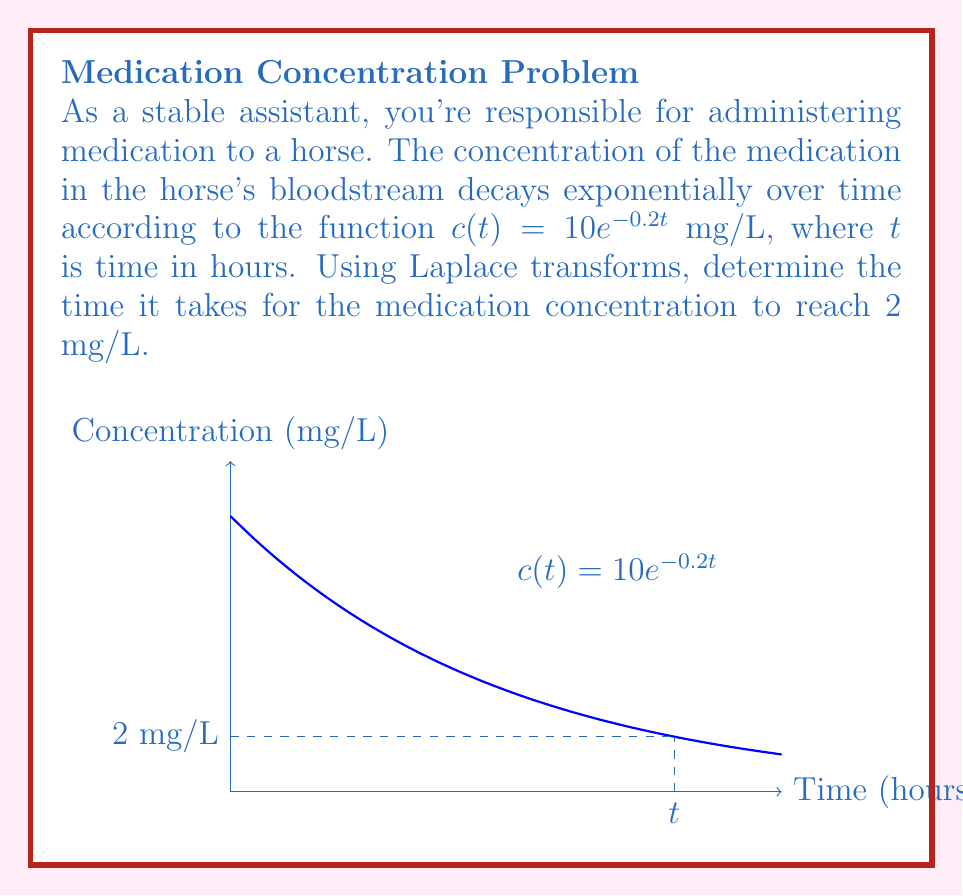Give your solution to this math problem. Let's solve this problem step by step using Laplace transforms:

1) We need to solve the equation:
   $$ 10e^{-0.2t} = 2 $$

2) Taking the natural logarithm of both sides:
   $$ \ln(10e^{-0.2t}) = \ln(2) $$
   $$ \ln(10) - 0.2t = \ln(2) $$

3) Solving for t:
   $$ -0.2t = \ln(2) - \ln(10) $$
   $$ -0.2t = \ln(2/10) $$
   $$ t = -\frac{\ln(2/10)}{0.2} $$

4) Simplifying:
   $$ t = -\frac{\ln(0.2)}{0.2} $$
   $$ t = \frac{\ln(5)}{0.2} $$

5) Calculating the final value:
   $$ t \approx 8.05 \text{ hours} $$

Therefore, it takes approximately 8.05 hours for the medication concentration to reach 2 mg/L.
Answer: $\frac{\ln(5)}{0.2} \approx 8.05$ hours 